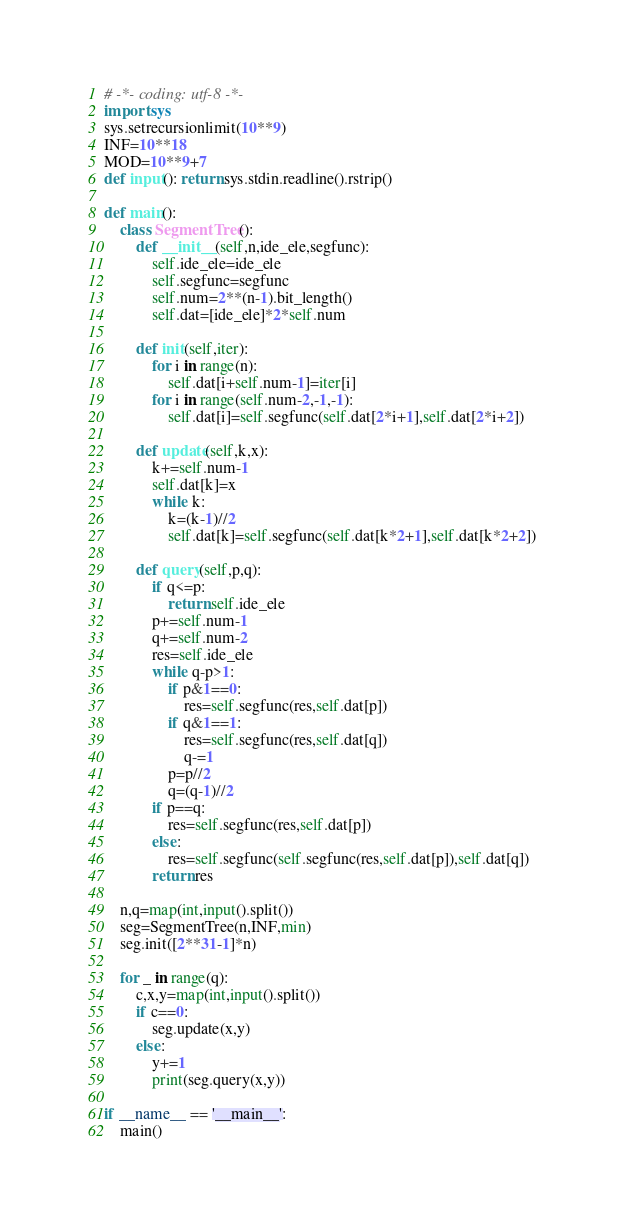Convert code to text. <code><loc_0><loc_0><loc_500><loc_500><_Python_># -*- coding: utf-8 -*-
import sys
sys.setrecursionlimit(10**9)
INF=10**18
MOD=10**9+7
def input(): return sys.stdin.readline().rstrip()

def main():
    class SegmentTree():
        def __init__(self,n,ide_ele,segfunc):
            self.ide_ele=ide_ele
            self.segfunc=segfunc
            self.num=2**(n-1).bit_length()
            self.dat=[ide_ele]*2*self.num
        
        def init(self,iter):
            for i in range(n):
                self.dat[i+self.num-1]=iter[i]
            for i in range(self.num-2,-1,-1):
                self.dat[i]=self.segfunc(self.dat[2*i+1],self.dat[2*i+2])
        
        def update(self,k,x):
            k+=self.num-1
            self.dat[k]=x
            while k:
                k=(k-1)//2
                self.dat[k]=self.segfunc(self.dat[k*2+1],self.dat[k*2+2])
        
        def query(self,p,q):
            if q<=p:
                return self.ide_ele
            p+=self.num-1
            q+=self.num-2
            res=self.ide_ele
            while q-p>1:
                if p&1==0:
                    res=self.segfunc(res,self.dat[p])
                if q&1==1:
                    res=self.segfunc(res,self.dat[q])
                    q-=1
                p=p//2
                q=(q-1)//2
            if p==q:
                res=self.segfunc(res,self.dat[p])
            else:
                res=self.segfunc(self.segfunc(res,self.dat[p]),self.dat[q])
            return res
    
    n,q=map(int,input().split())
    seg=SegmentTree(n,INF,min)
    seg.init([2**31-1]*n)
    
    for _ in range(q):
        c,x,y=map(int,input().split())
        if c==0:
            seg.update(x,y)
        else:
            y+=1
            print(seg.query(x,y))

if __name__ == '__main__':
    main()

</code> 